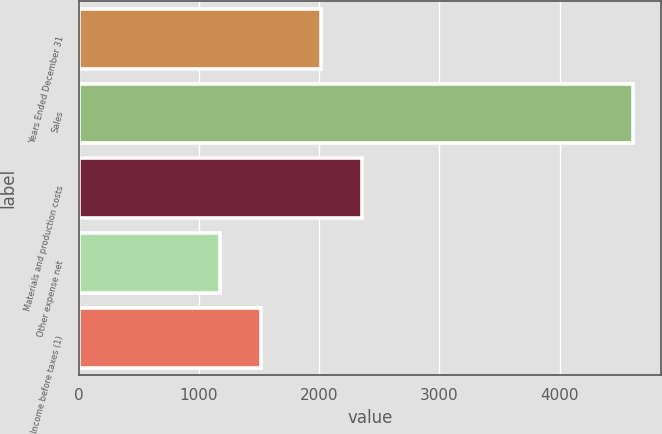<chart> <loc_0><loc_0><loc_500><loc_500><bar_chart><fcel>Years Ended December 31<fcel>Sales<fcel>Materials and production costs<fcel>Other expense net<fcel>Income before taxes (1)<nl><fcel>2013<fcel>4611<fcel>2356.6<fcel>1175<fcel>1518.6<nl></chart> 